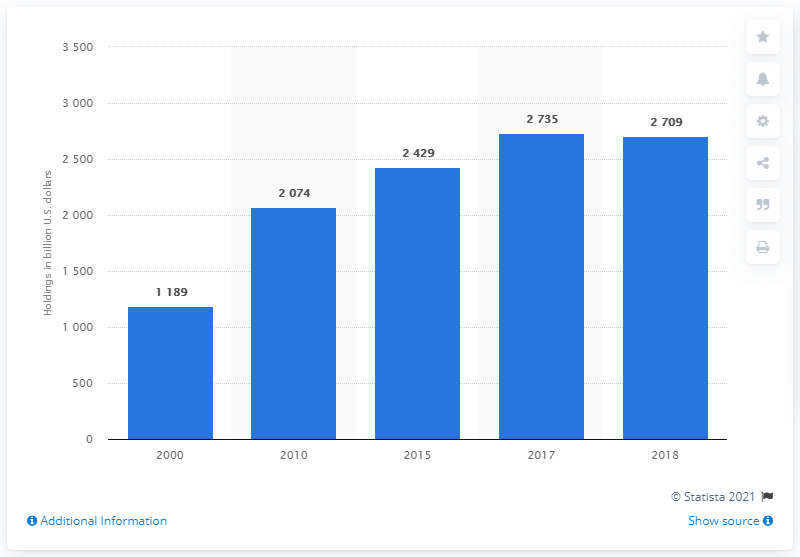Give some essential details in this illustration. In 2018, a total of 2709 U.S. dollars were held by life insurance companies. 